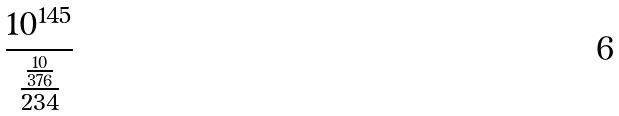<formula> <loc_0><loc_0><loc_500><loc_500>\frac { 1 0 ^ { 1 4 5 } } { \frac { \frac { 1 0 } { 3 7 6 } } { 2 3 4 } }</formula> 